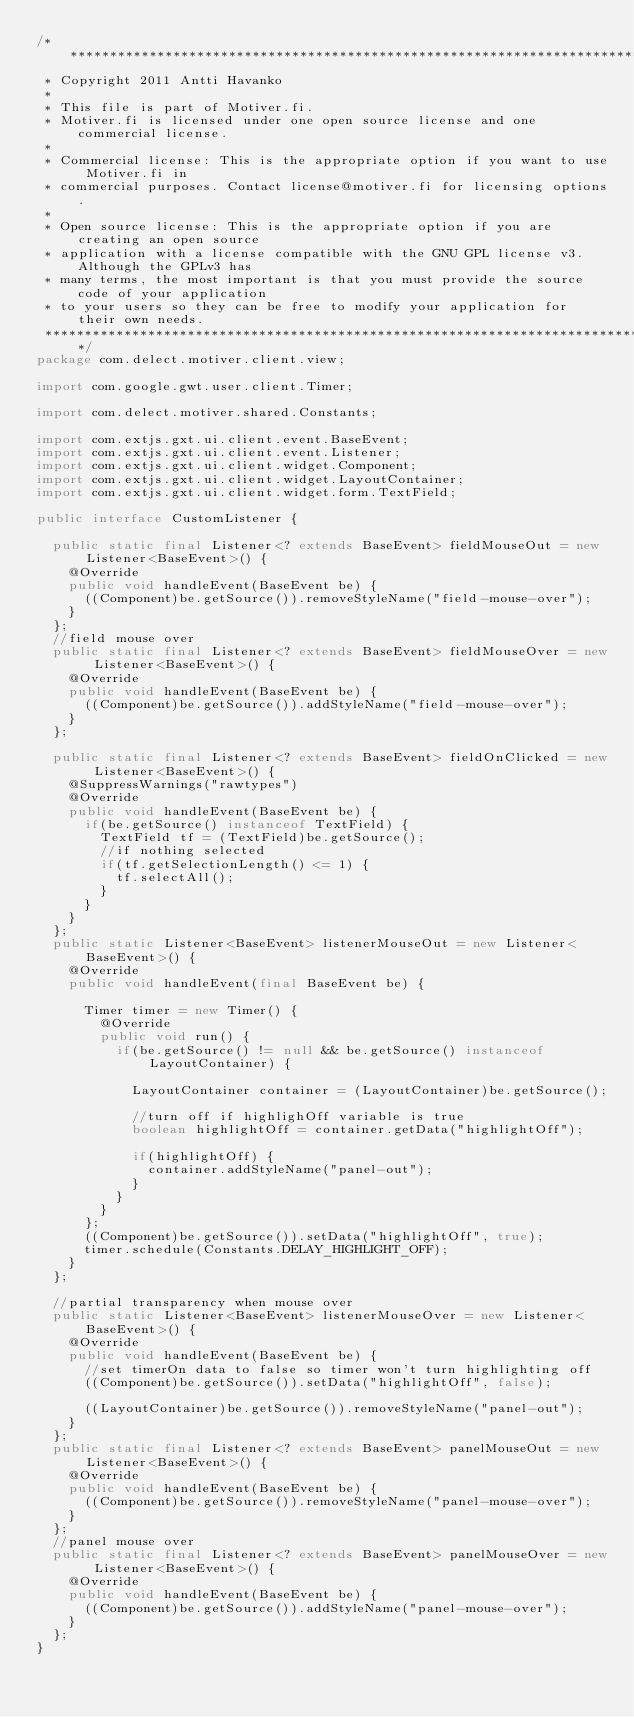Convert code to text. <code><loc_0><loc_0><loc_500><loc_500><_Java_>/*******************************************************************************
 * Copyright 2011 Antti Havanko
 * 
 * This file is part of Motiver.fi.
 * Motiver.fi is licensed under one open source license and one commercial license.
 * 
 * Commercial license: This is the appropriate option if you want to use Motiver.fi in 
 * commercial purposes. Contact license@motiver.fi for licensing options.
 * 
 * Open source license: This is the appropriate option if you are creating an open source 
 * application with a license compatible with the GNU GPL license v3. Although the GPLv3 has 
 * many terms, the most important is that you must provide the source code of your application 
 * to your users so they can be free to modify your application for their own needs.
 ******************************************************************************/
package com.delect.motiver.client.view;

import com.google.gwt.user.client.Timer;

import com.delect.motiver.shared.Constants;

import com.extjs.gxt.ui.client.event.BaseEvent;
import com.extjs.gxt.ui.client.event.Listener;
import com.extjs.gxt.ui.client.widget.Component;
import com.extjs.gxt.ui.client.widget.LayoutContainer;
import com.extjs.gxt.ui.client.widget.form.TextField;

public interface CustomListener {

	public static final Listener<? extends BaseEvent> fieldMouseOut = new Listener<BaseEvent>() {
		@Override
		public void handleEvent(BaseEvent be) {
			((Component)be.getSource()).removeStyleName("field-mouse-over");
		}
	};
	//field mouse over
	public static final Listener<? extends BaseEvent> fieldMouseOver = new Listener<BaseEvent>() {
		@Override
		public void handleEvent(BaseEvent be) {
			((Component)be.getSource()).addStyleName("field-mouse-over");
		}
	};
	
	public static final Listener<? extends BaseEvent> fieldOnClicked = new Listener<BaseEvent>() {
    @SuppressWarnings("rawtypes")
    @Override
    public void handleEvent(BaseEvent be) {
      if(be.getSource() instanceof TextField) {
        TextField tf = (TextField)be.getSource();
        //if nothing selected
        if(tf.getSelectionLength() <= 1) {
          tf.selectAll();
        }
      }
    }
  };
	public static Listener<BaseEvent> listenerMouseOut = new Listener<BaseEvent>() {
		@Override
		public void handleEvent(final BaseEvent be) {

			Timer timer = new Timer() {
				@Override
				public void run() {
				  if(be.getSource() != null && be.getSource() instanceof LayoutContainer) {
				    
				    LayoutContainer container = (LayoutContainer)be.getSource();
				    
						//turn off if highlighOff variable is true
						boolean highlightOff = container.getData("highlightOff");
						
						if(highlightOff) {
						  container.addStyleName("panel-out");
						}
				  }
				}
			};
			((Component)be.getSource()).setData("highlightOff", true);
			timer.schedule(Constants.DELAY_HIGHLIGHT_OFF);
		}
	};

	//partial transparency when mouse over
	public static Listener<BaseEvent> listenerMouseOver = new Listener<BaseEvent>() {
		@Override
		public void handleEvent(BaseEvent be) {
			//set timerOn data to false so timer won't turn highlighting off
			((Component)be.getSource()).setData("highlightOff", false);
			
			((LayoutContainer)be.getSource()).removeStyleName("panel-out");
		}
	};
	public static final Listener<? extends BaseEvent> panelMouseOut = new Listener<BaseEvent>() {
		@Override
		public void handleEvent(BaseEvent be) {
			((Component)be.getSource()).removeStyleName("panel-mouse-over");
		}
	};
	//panel mouse over
	public static final Listener<? extends BaseEvent> panelMouseOver = new Listener<BaseEvent>() {
		@Override
		public void handleEvent(BaseEvent be) {			
			((Component)be.getSource()).addStyleName("panel-mouse-over");
		}
	};
}
</code> 